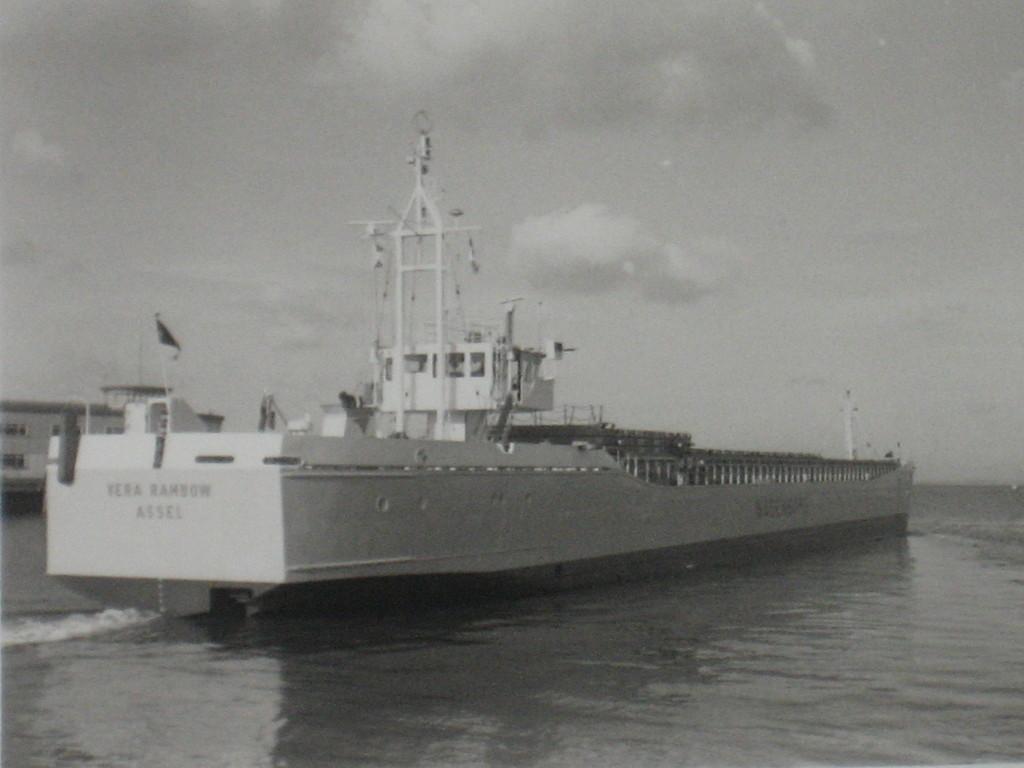What is the color scheme of the image? The image is black and white. What is the main subject of the image? There is a ship in the image. What is located at the bottom of the image? There is water at the bottom of the image. What is visible at the top of the image? The sky is visible at the top of the image. What can be seen in the sky? Clouds are present in the sky. What type of bath can be seen in the image? There is no bath present in the image; it features a ship and water. What territory is being claimed by the ship in the image? The image does not indicate any territorial claims or disputes; it simply shows a ship on water with a sky above. 